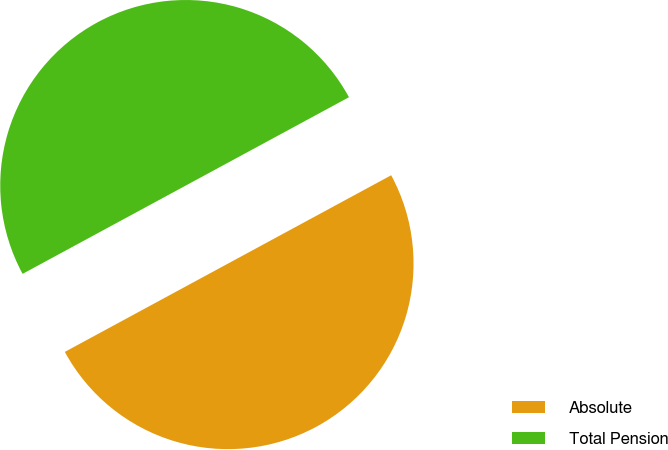<chart> <loc_0><loc_0><loc_500><loc_500><pie_chart><fcel>Absolute<fcel>Total Pension<nl><fcel>50.0%<fcel>50.0%<nl></chart> 